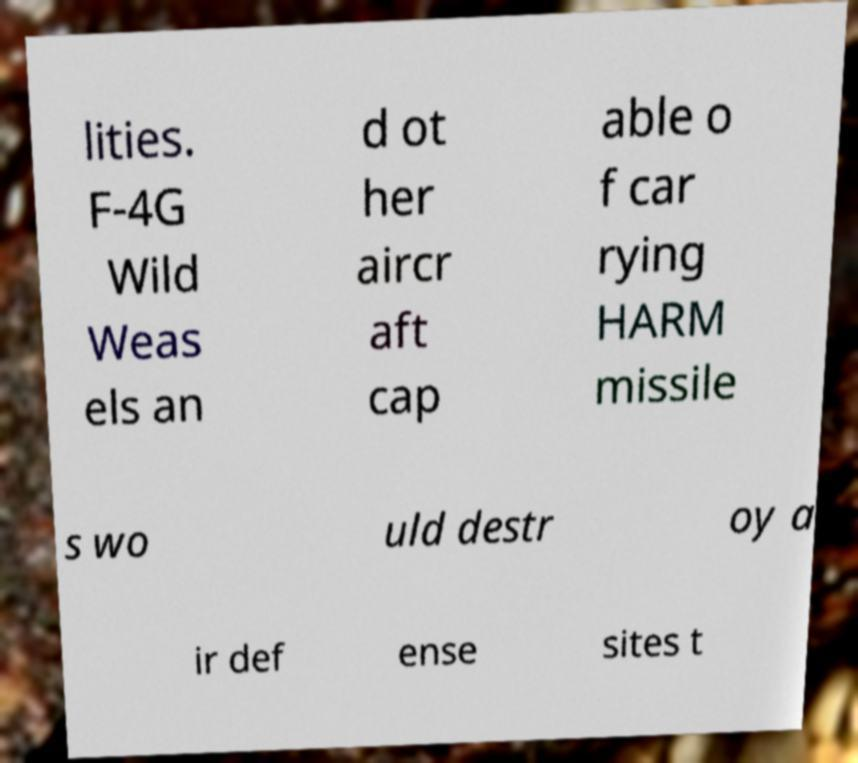Can you accurately transcribe the text from the provided image for me? lities. F-4G Wild Weas els an d ot her aircr aft cap able o f car rying HARM missile s wo uld destr oy a ir def ense sites t 